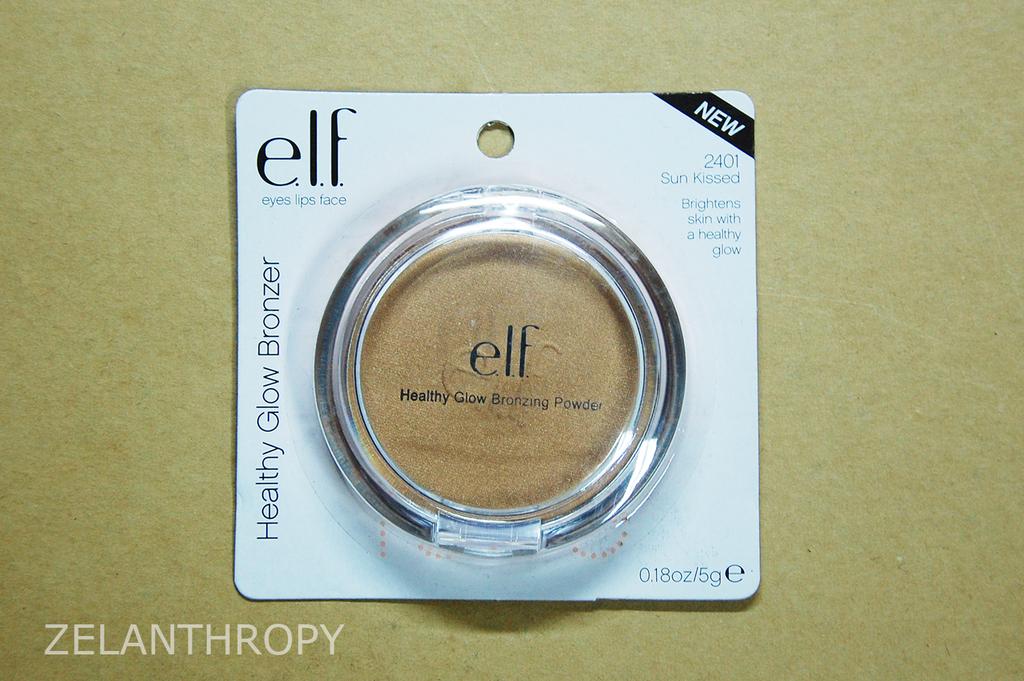What company makes this?
Provide a succinct answer. Elf. What kind of compact is this?
Your answer should be very brief. Elf. 